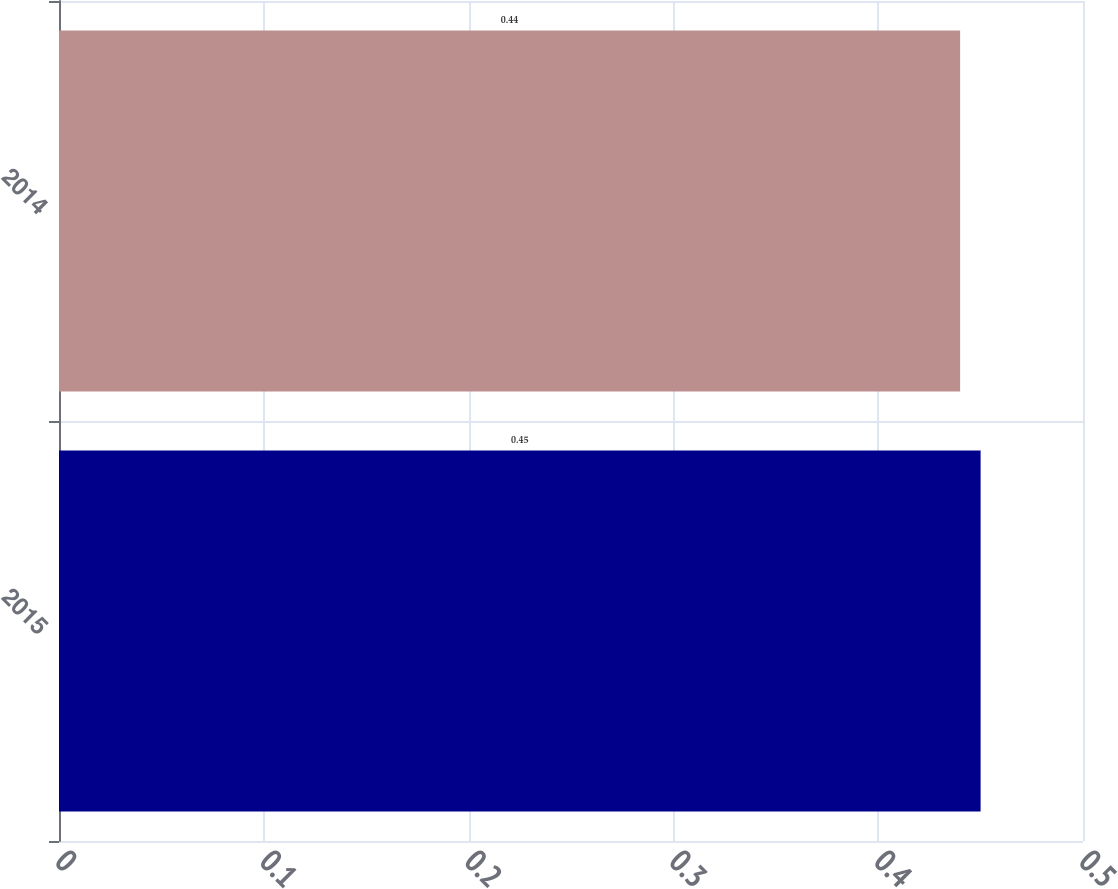Convert chart to OTSL. <chart><loc_0><loc_0><loc_500><loc_500><bar_chart><fcel>2015<fcel>2014<nl><fcel>0.45<fcel>0.44<nl></chart> 